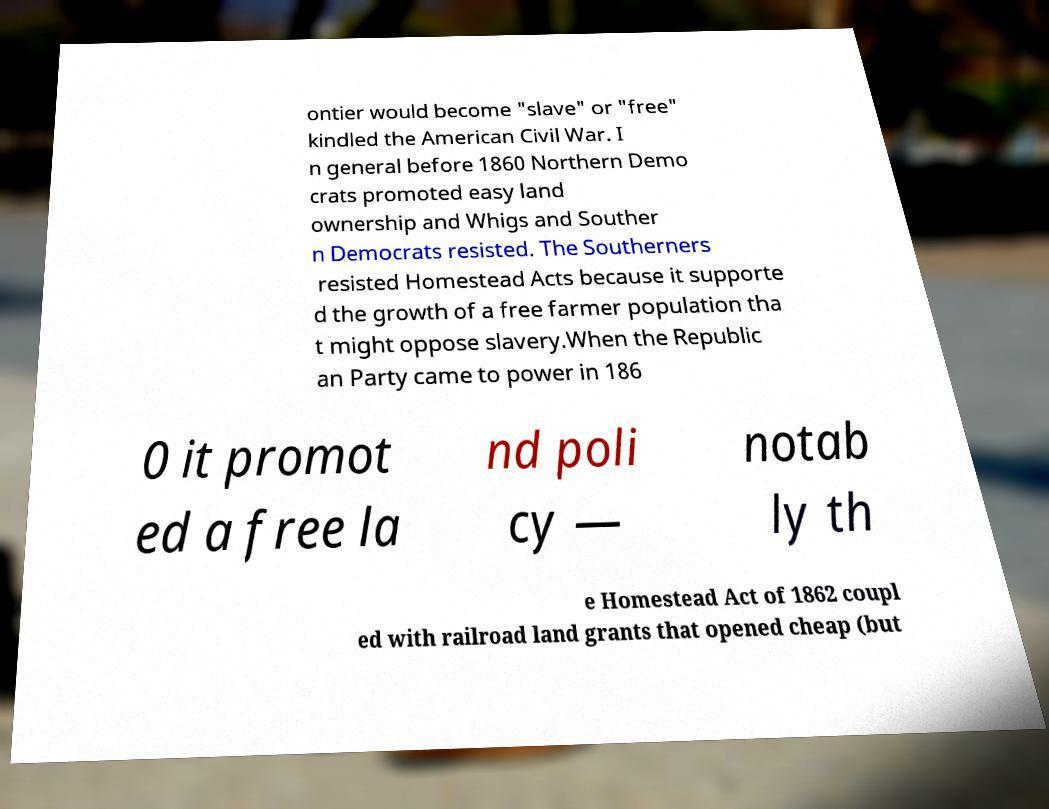For documentation purposes, I need the text within this image transcribed. Could you provide that? ontier would become "slave" or "free" kindled the American Civil War. I n general before 1860 Northern Demo crats promoted easy land ownership and Whigs and Souther n Democrats resisted. The Southerners resisted Homestead Acts because it supporte d the growth of a free farmer population tha t might oppose slavery.When the Republic an Party came to power in 186 0 it promot ed a free la nd poli cy — notab ly th e Homestead Act of 1862 coupl ed with railroad land grants that opened cheap (but 